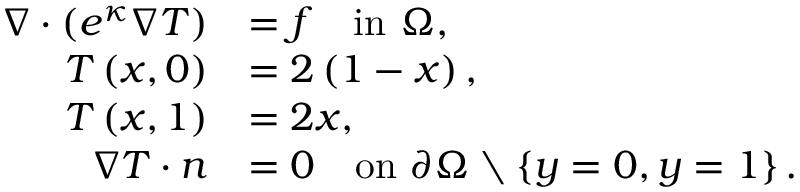<formula> <loc_0><loc_0><loc_500><loc_500>\begin{array} { r l } { \nabla \cdot \left ( e ^ { \kappa } \nabla T \right ) } & { = f \quad i n \Omega , } \\ { T \left ( x , 0 \right ) } & { = 2 \left ( 1 - x \right ) , } \\ { T \left ( x , 1 \right ) } & { = 2 x , } \\ { \nabla T \cdot n } & { = 0 \quad o n \partial \Omega \ \left \{ y = 0 , y = 1 \right \} . } \end{array}</formula> 